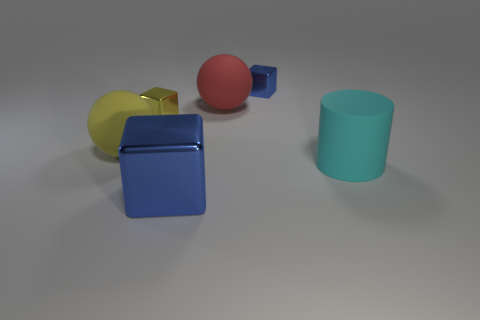Can you tell me what shapes are present in the image? Certainly! The image displays a variety of geometric shapes including a blue cube, a yellow cube, a red sphere, a smaller blue sphere, and a teal cylinder. 